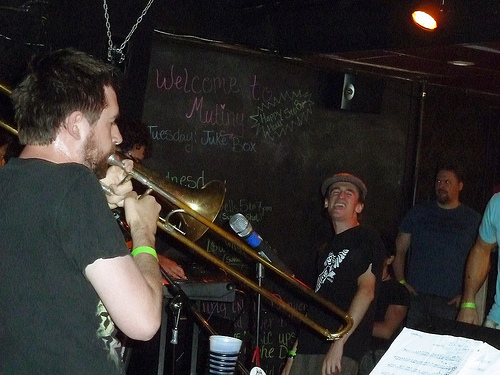<image>
Is the man in front of the instrument? Yes. The man is positioned in front of the instrument, appearing closer to the camera viewpoint. 